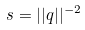Convert formula to latex. <formula><loc_0><loc_0><loc_500><loc_500>s = | | q | | ^ { - 2 }</formula> 